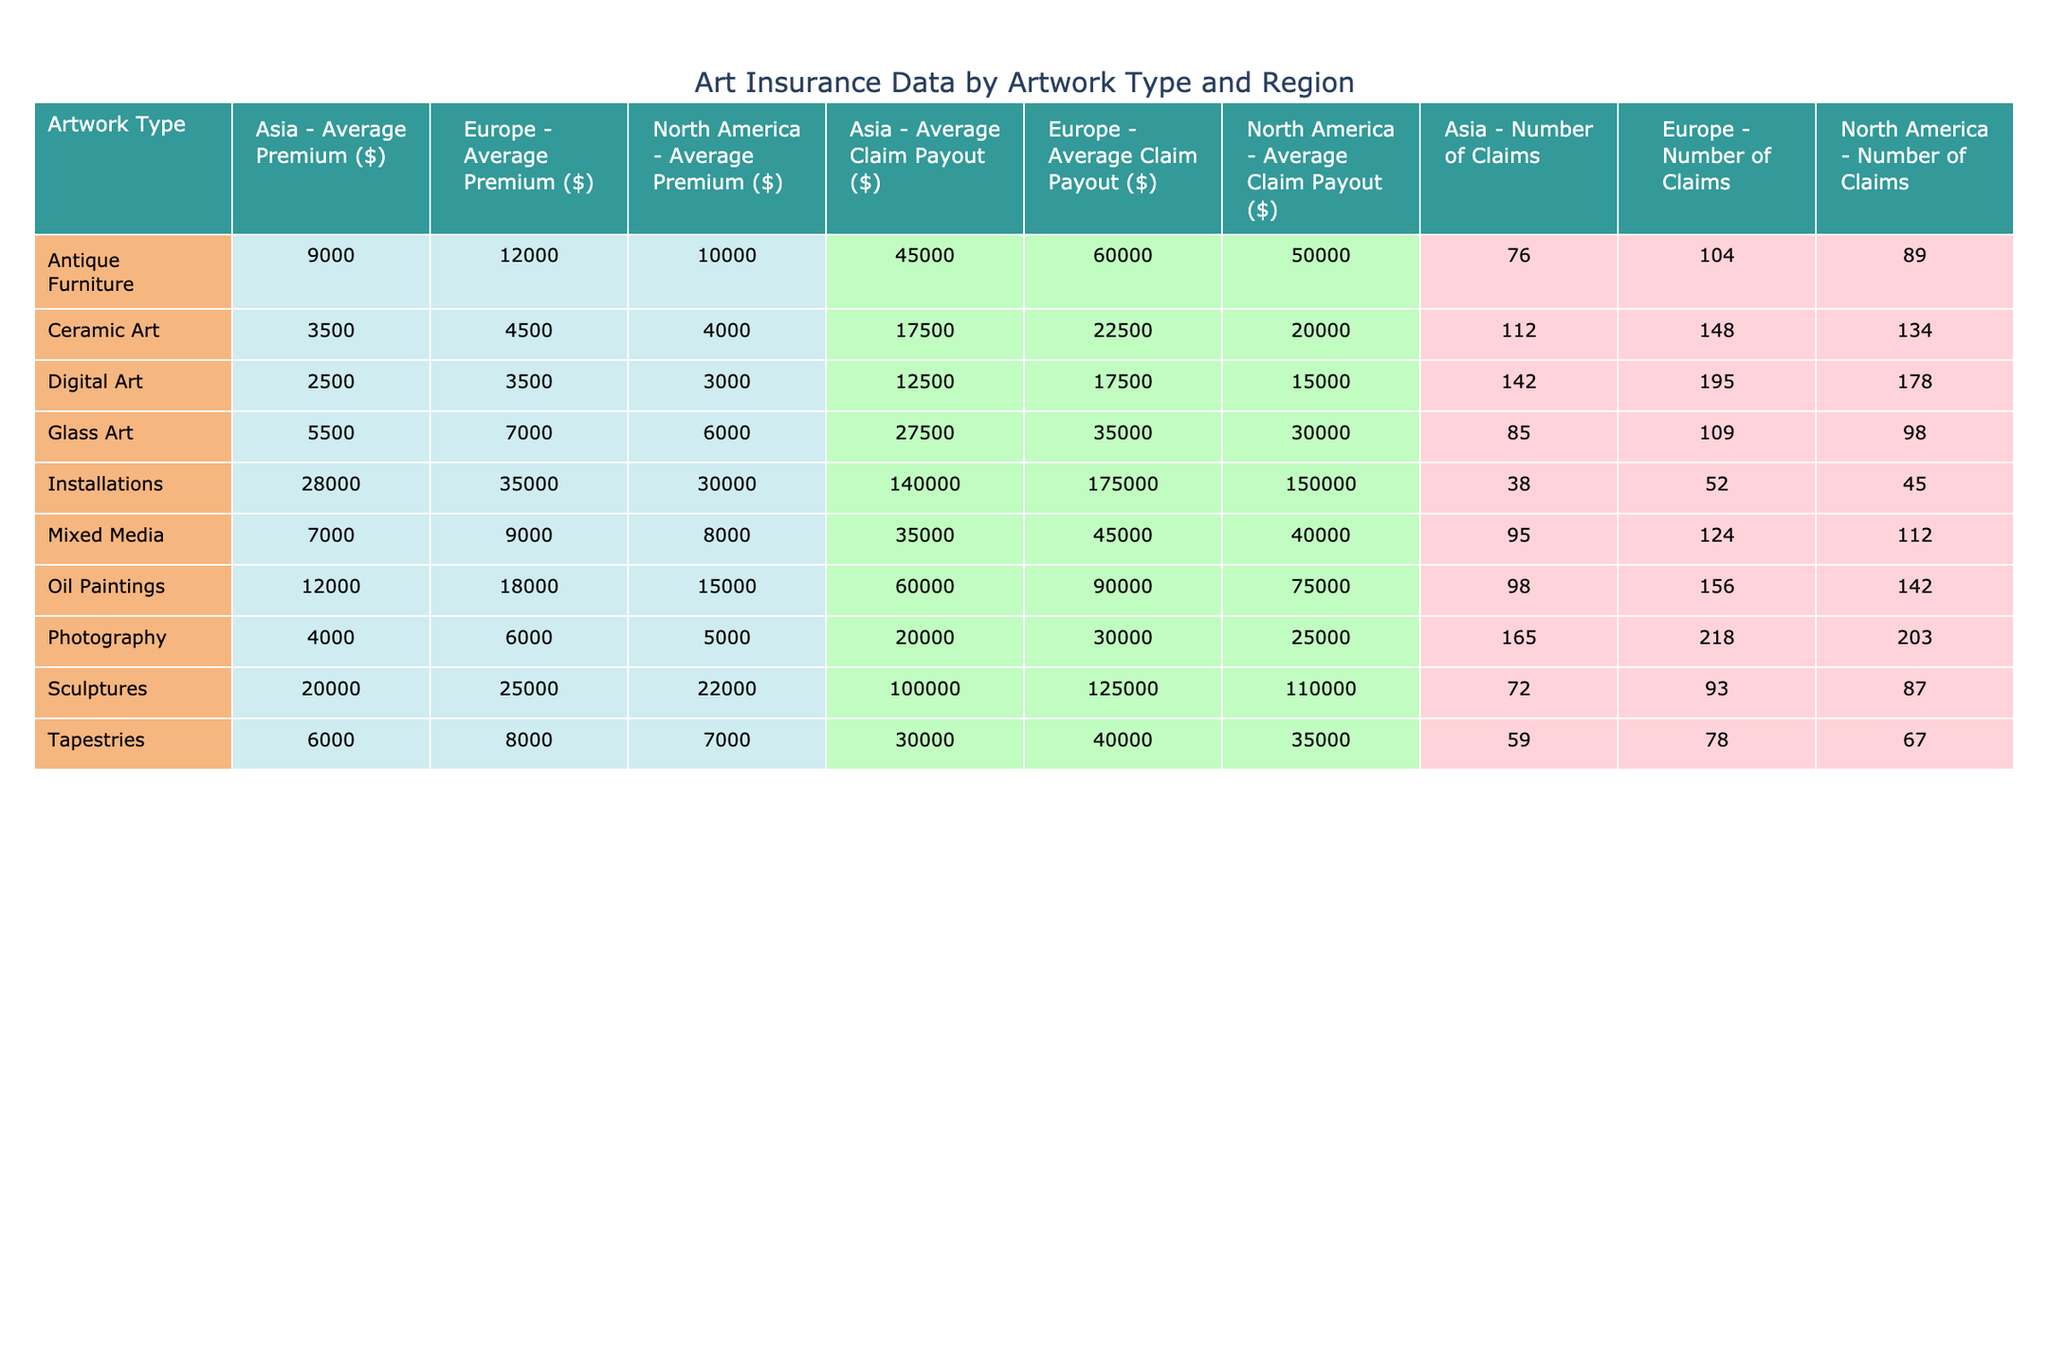What is the average claim payout for sculptures in Europe? The table shows that the average claim payout for sculptures in Europe is 125,000 dollars.
Answer: 125000 Which artwork type in Asia has the lowest average premium? According to the table, the artwork type in Asia with the lowest average premium is Digital Art, with an average premium of 2,500 dollars.
Answer: 2500 How many claims were made for oil paintings in North America? Looking at the table, there were a total of 142 claims made for oil paintings in North America.
Answer: 142 What is the average premium for photography in North America compared to Asia? The average premium for photography in North America is 5,000 dollars, while in Asia it is 4,000 dollars. The difference is 1,000 dollars, with North America having a higher average premium.
Answer: 1000 Is the average claim payout for mixed media in Europe greater than the average premium for sculptures in North America? The average claim payout for mixed media in Europe is 45,000 dollars, while the average premium for sculptures in North America is 22,000 dollars. Since 45,000 is greater than 22,000, the statement is true.
Answer: Yes What is the total number of claims made across all artwork types in North America? Summing the number of claims for each artwork type in North America: 142 (Oil Paintings) + 87 (Sculptures) + 203 (Photography) + 112 (Mixed Media) + 45 (Installations) + 178 (Digital Art) + 89 (Antique Furniture) + 67 (Tapestries) + 134 (Ceramic Art) + 98 (Glass Art) equals 1110 claims in total.
Answer: 1110 Which region has the highest average claim payout for installations? From the table, Europe has the highest average claim payout for installations at 175,000 dollars, compared to North America at 150,000 dollars and Asia at 140,000 dollars.
Answer: 175000 Are antique furniture claims in Europe more than the average premium for ceramics in Asia? The average claim payout for antique furniture in Europe is 60,000 dollars, while the average premium for ceramics in Asia is 3,500 dollars. Since 60,000 is indeed more than 3,500, the statement is true.
Answer: Yes What is the average claim payout for photography across all regions? To find the average claim payout for photography, we calculate: (25,000 + 30,000 + 20,000)/3 = 25,000 dollars. Thus the average claim payout for photography across all regions is 25,000 dollars.
Answer: 25000 Which artwork type has the highest average premium in North America? According to the table, installations have the highest average premium in North America at 30,000 dollars.
Answer: 30000 